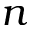Convert formula to latex. <formula><loc_0><loc_0><loc_500><loc_500>n</formula> 